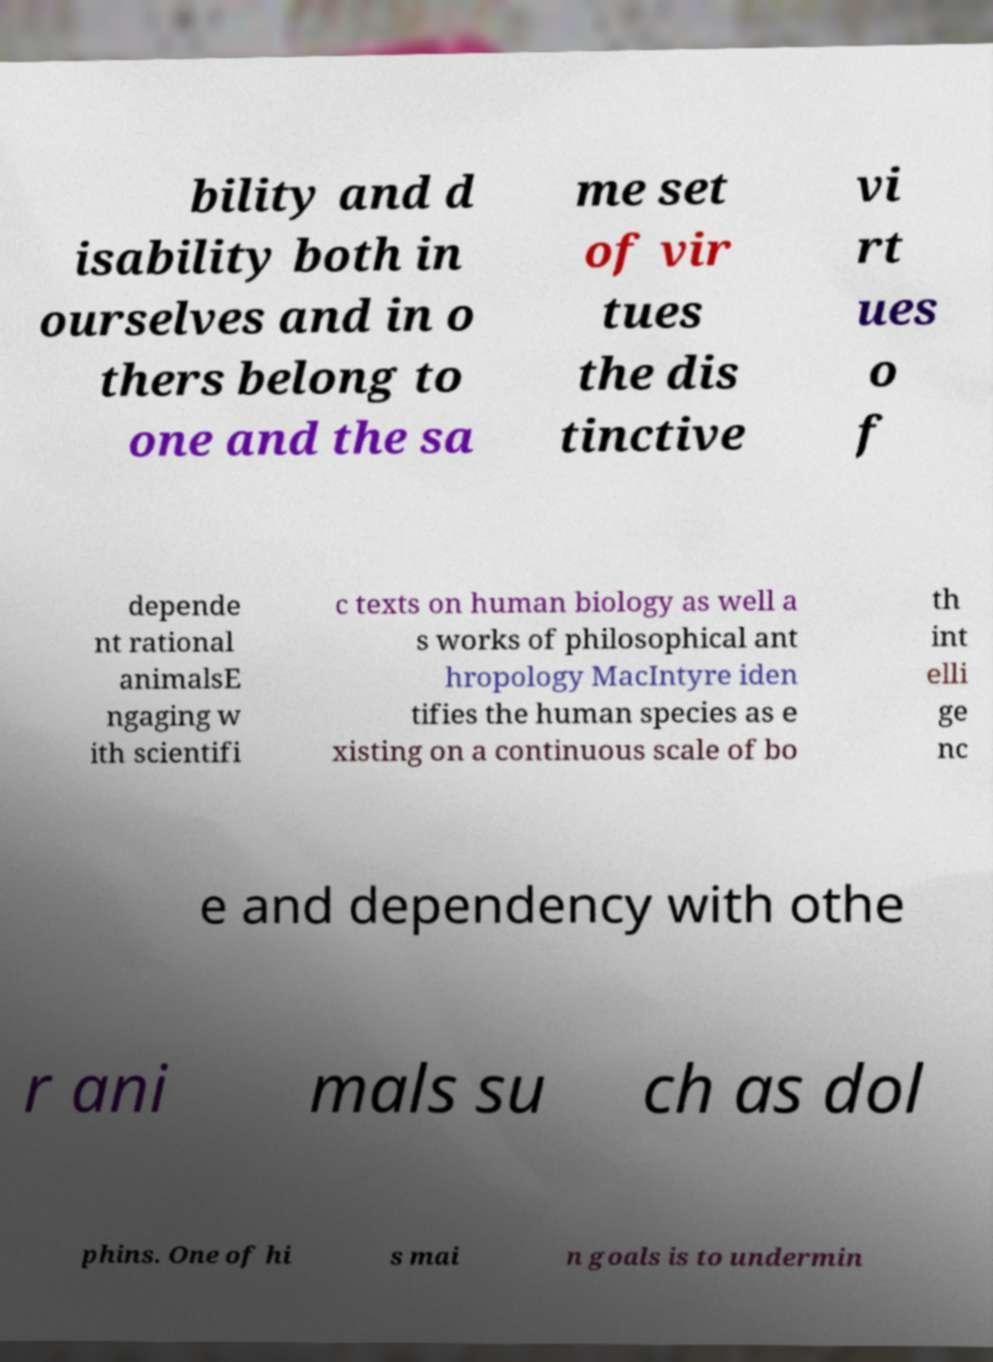Could you extract and type out the text from this image? bility and d isability both in ourselves and in o thers belong to one and the sa me set of vir tues the dis tinctive vi rt ues o f depende nt rational animalsE ngaging w ith scientifi c texts on human biology as well a s works of philosophical ant hropology MacIntyre iden tifies the human species as e xisting on a continuous scale of bo th int elli ge nc e and dependency with othe r ani mals su ch as dol phins. One of hi s mai n goals is to undermin 